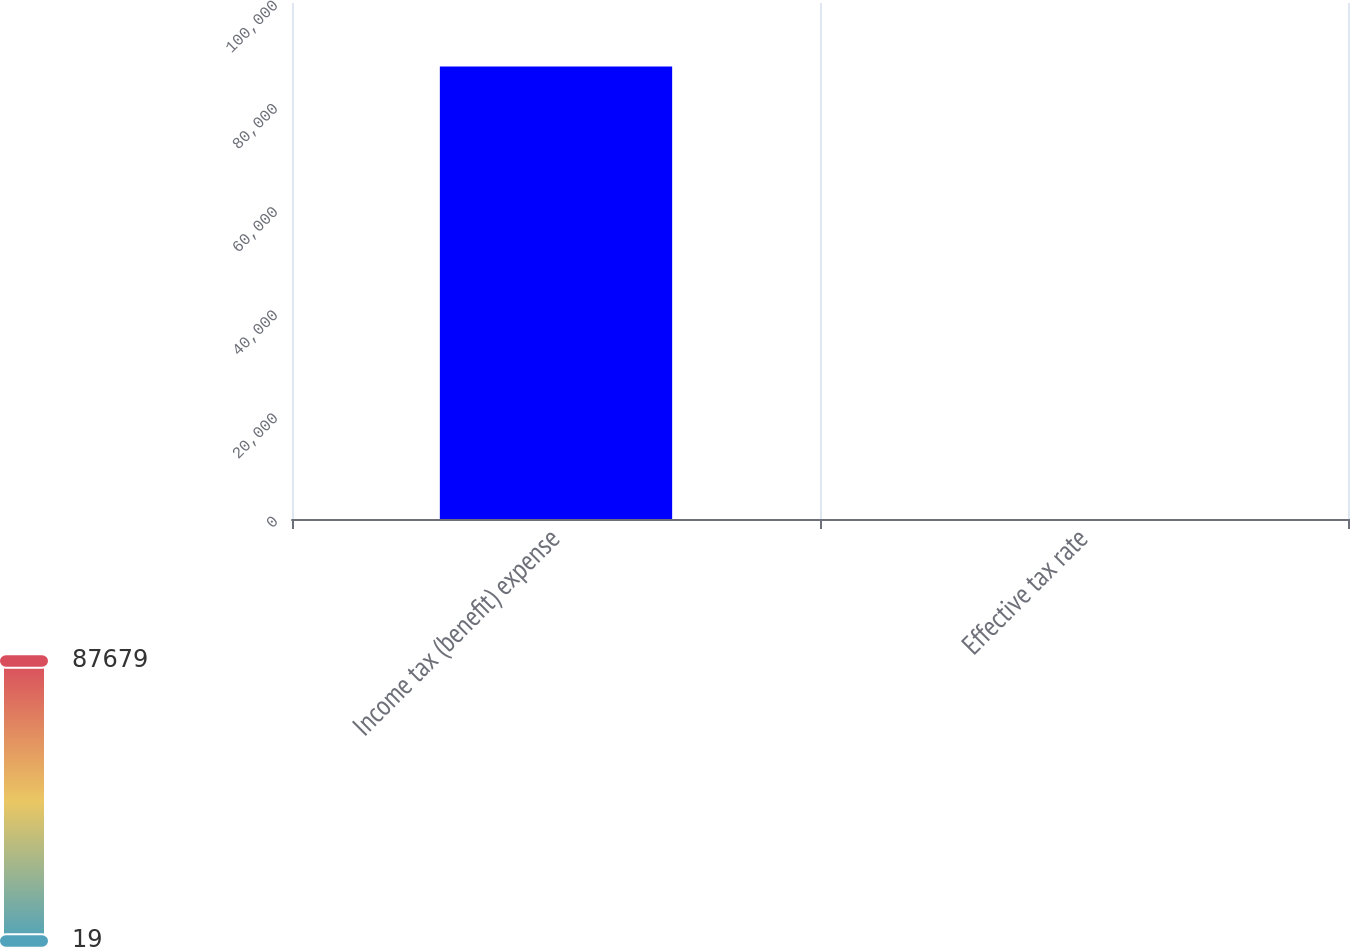Convert chart. <chart><loc_0><loc_0><loc_500><loc_500><bar_chart><fcel>Income tax (benefit) expense<fcel>Effective tax rate<nl><fcel>87679<fcel>19<nl></chart> 